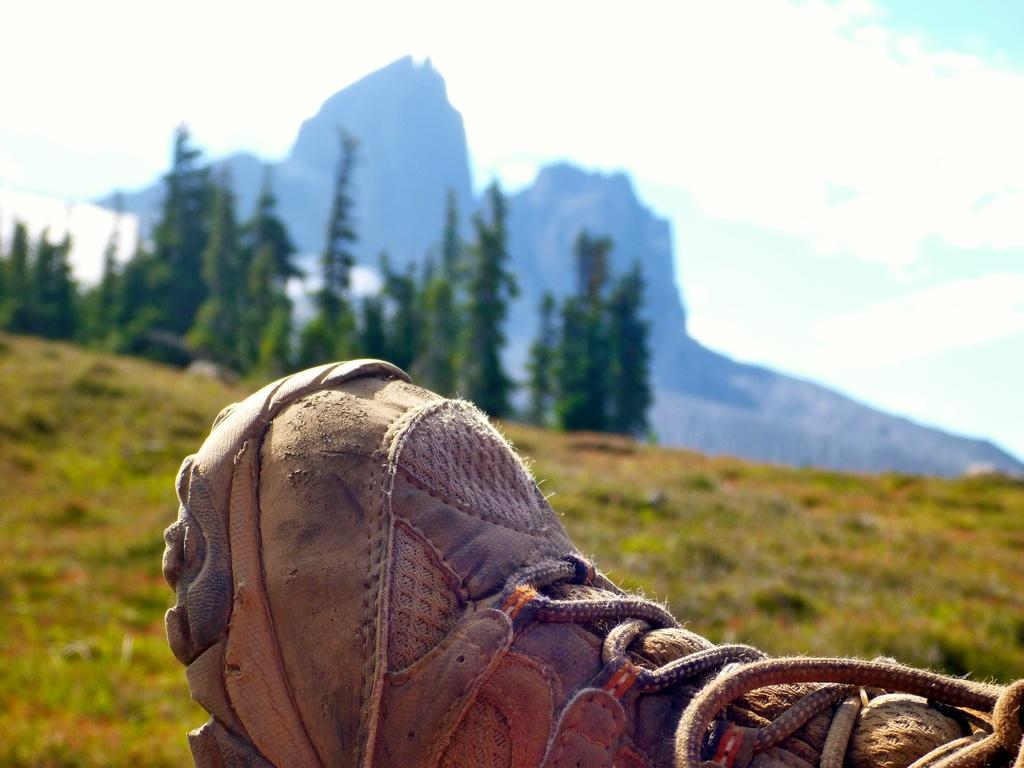What object is located in the foreground of the image? There is a shoe in the foreground of the image. What type of natural landscape can be seen in the background of the image? There is a mountain, trees, and grass in the background of the image. What type of engine can be seen powering the houses in the image? There are no houses or engines present in the image. 